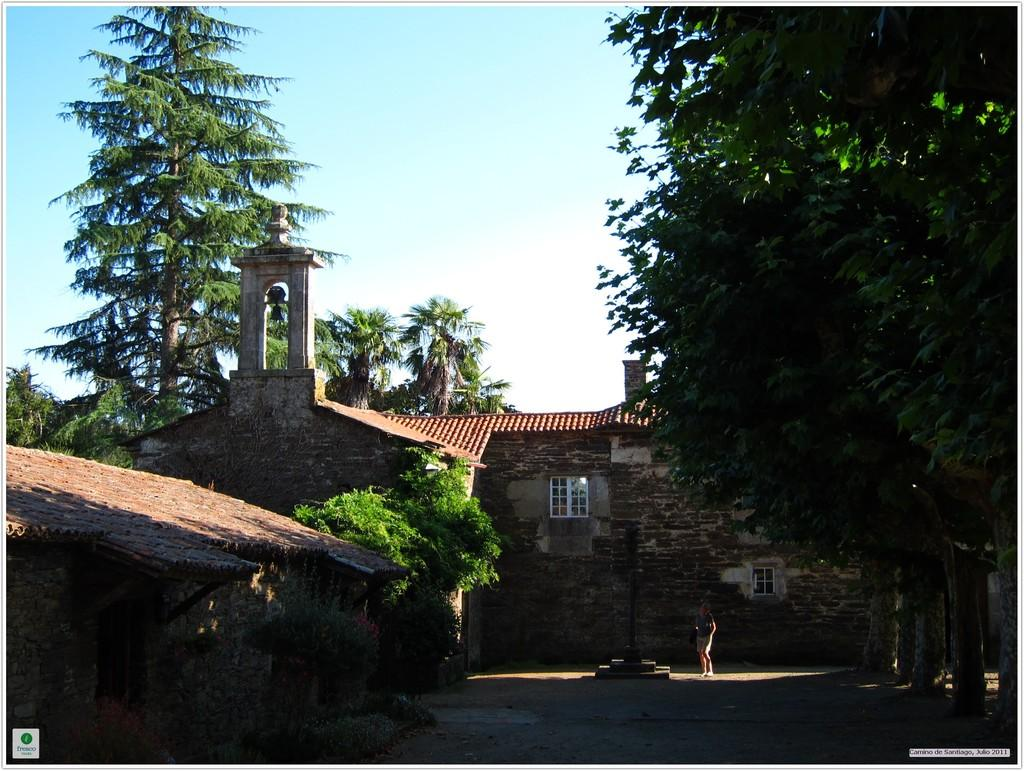What type of structure is present in the image? There is a shelter house in the image. Where is the shelter house situated? The shelter house is located between trees. Can you describe the person's position in the image? There is a person standing in front of a pole. What is visible at the top of the image? The sky is visible at the top of the image. What type of jam is being spread on the bone in the image? There is no jam or bone present in the image. What kind of growth can be seen on the trees in the image? The image does not show any specific growth on the trees; it only shows the trees surrounding the shelter house. 